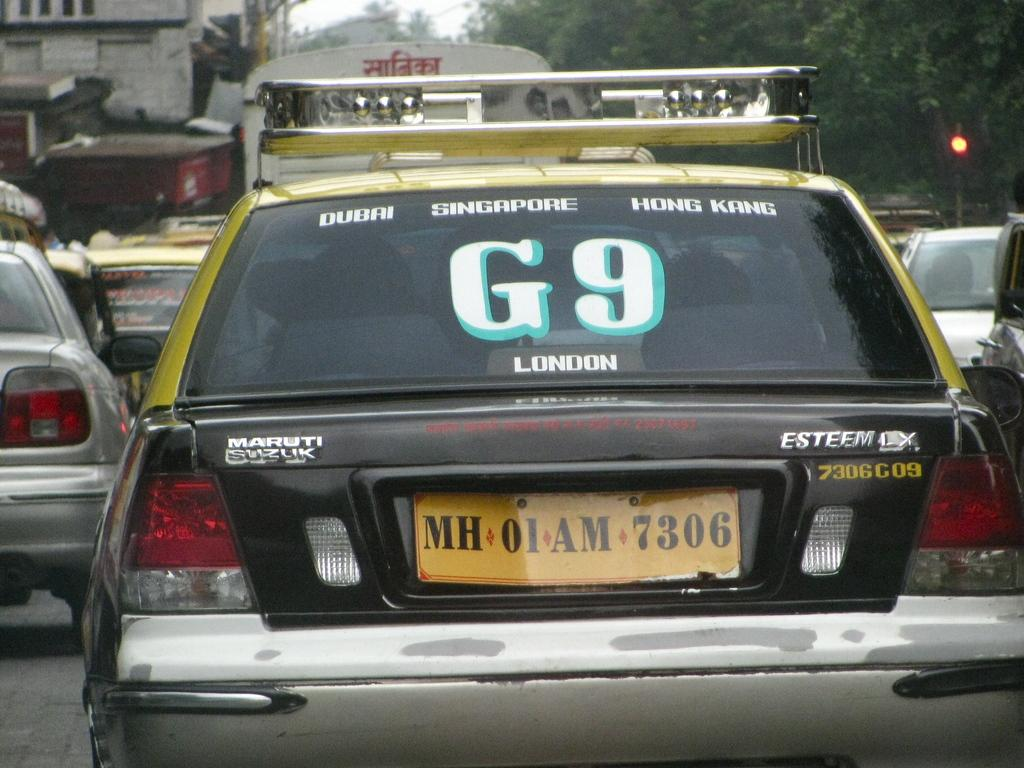<image>
Describe the image concisely. A car has G9 in the window and is the model esteem. 